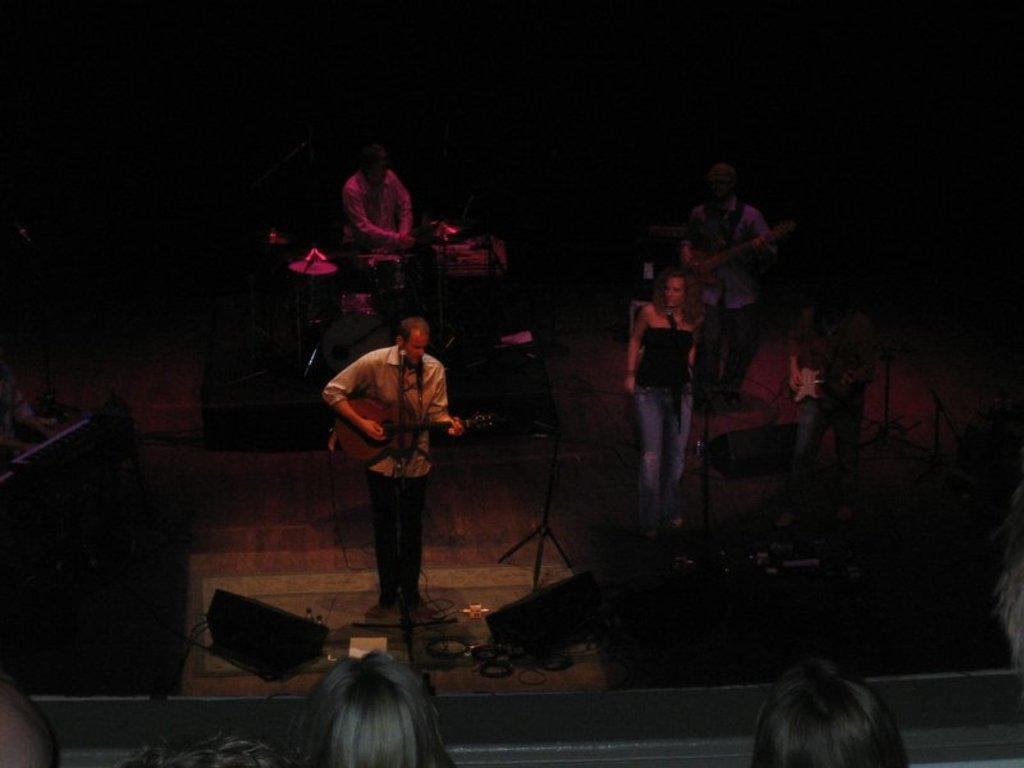What type of group is present in the image? There is a music band in the image. What are the band members doing? The band members are playing different musical instruments. Is there a vocalist in the image? Yes, there is a woman singing in the image. What can be observed about the lighting in the image? The background of the image is completely dark. What type of jelly can be seen on the floor in the image? There is no jelly present on the floor in the image. Can you tell me how many giraffes are in the background of the image? There are no giraffes present in the image; the background is completely dark. 